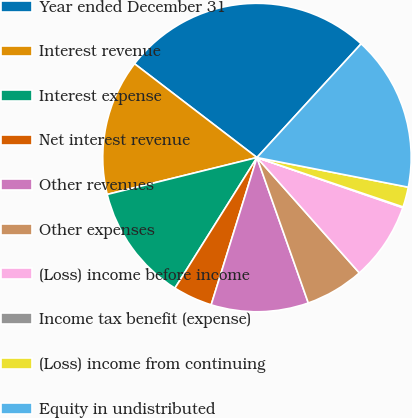Convert chart. <chart><loc_0><loc_0><loc_500><loc_500><pie_chart><fcel>Year ended December 31<fcel>Interest revenue<fcel>Interest expense<fcel>Net interest revenue<fcel>Other revenues<fcel>Other expenses<fcel>(Loss) income before income<fcel>Income tax benefit (expense)<fcel>(Loss) income from continuing<fcel>Equity in undistributed<nl><fcel>26.4%<fcel>14.25%<fcel>12.23%<fcel>4.13%<fcel>10.2%<fcel>6.15%<fcel>8.18%<fcel>0.08%<fcel>2.11%<fcel>16.28%<nl></chart> 